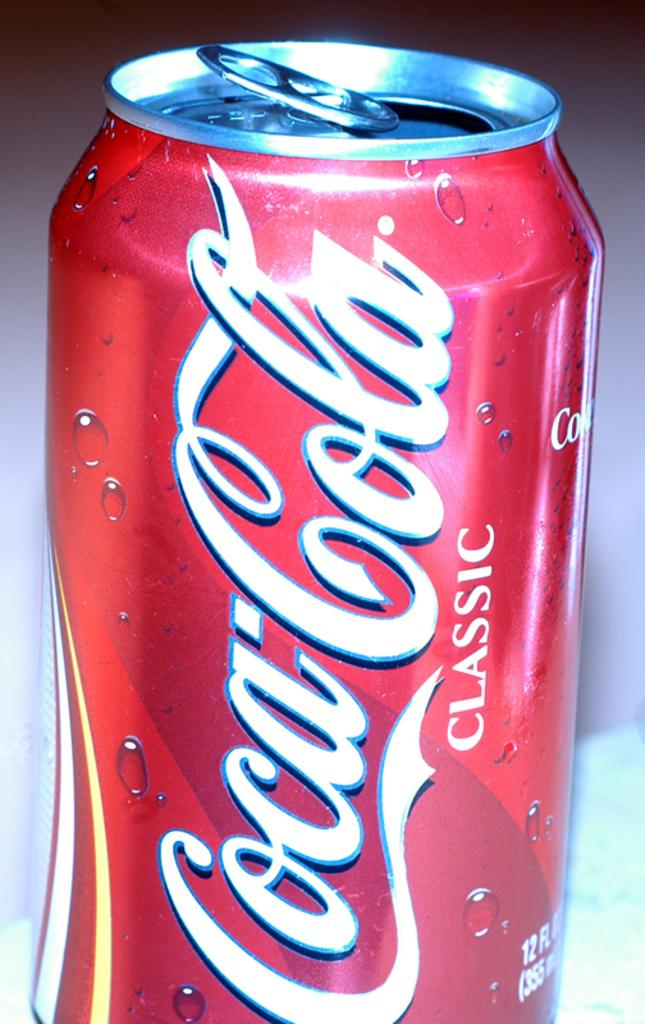Provide a one-sentence caption for the provided image. A red can of Cocacola Classic is opened. 